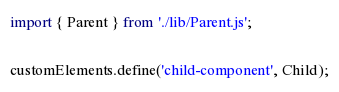<code> <loc_0><loc_0><loc_500><loc_500><_TypeScript_>import { Parent } from './lib/Parent.js';

customElements.define('child-component', Child);
</code> 